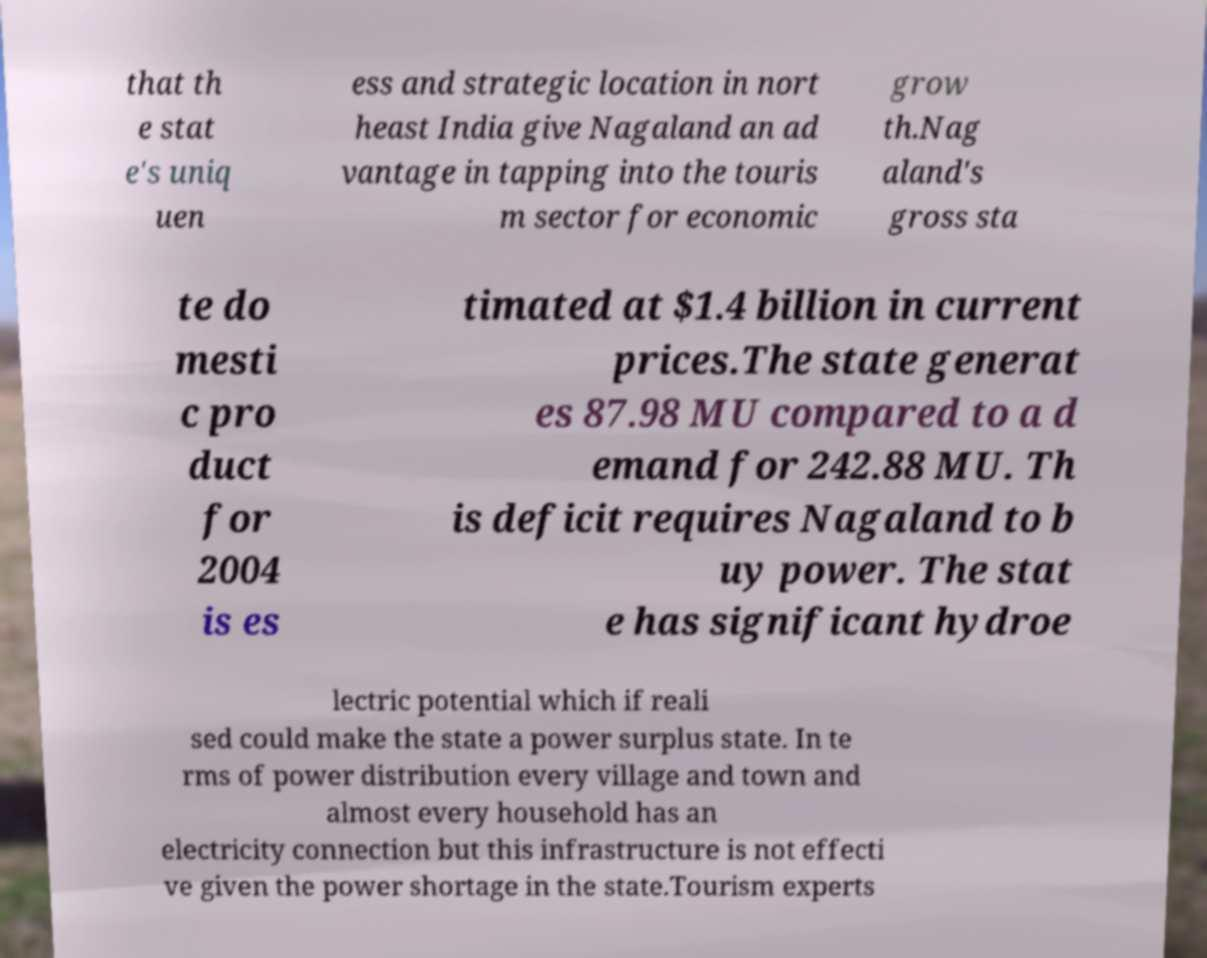For documentation purposes, I need the text within this image transcribed. Could you provide that? that th e stat e's uniq uen ess and strategic location in nort heast India give Nagaland an ad vantage in tapping into the touris m sector for economic grow th.Nag aland's gross sta te do mesti c pro duct for 2004 is es timated at $1.4 billion in current prices.The state generat es 87.98 MU compared to a d emand for 242.88 MU. Th is deficit requires Nagaland to b uy power. The stat e has significant hydroe lectric potential which if reali sed could make the state a power surplus state. In te rms of power distribution every village and town and almost every household has an electricity connection but this infrastructure is not effecti ve given the power shortage in the state.Tourism experts 